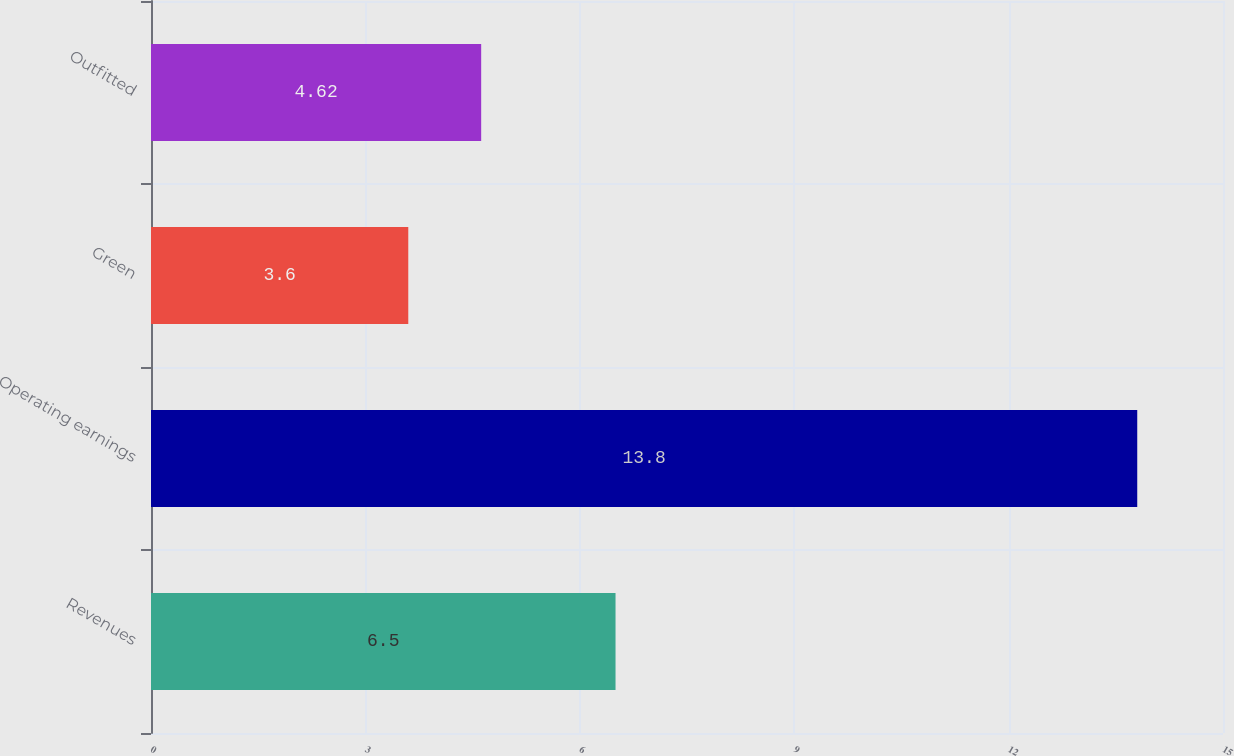Convert chart. <chart><loc_0><loc_0><loc_500><loc_500><bar_chart><fcel>Revenues<fcel>Operating earnings<fcel>Green<fcel>Outfitted<nl><fcel>6.5<fcel>13.8<fcel>3.6<fcel>4.62<nl></chart> 